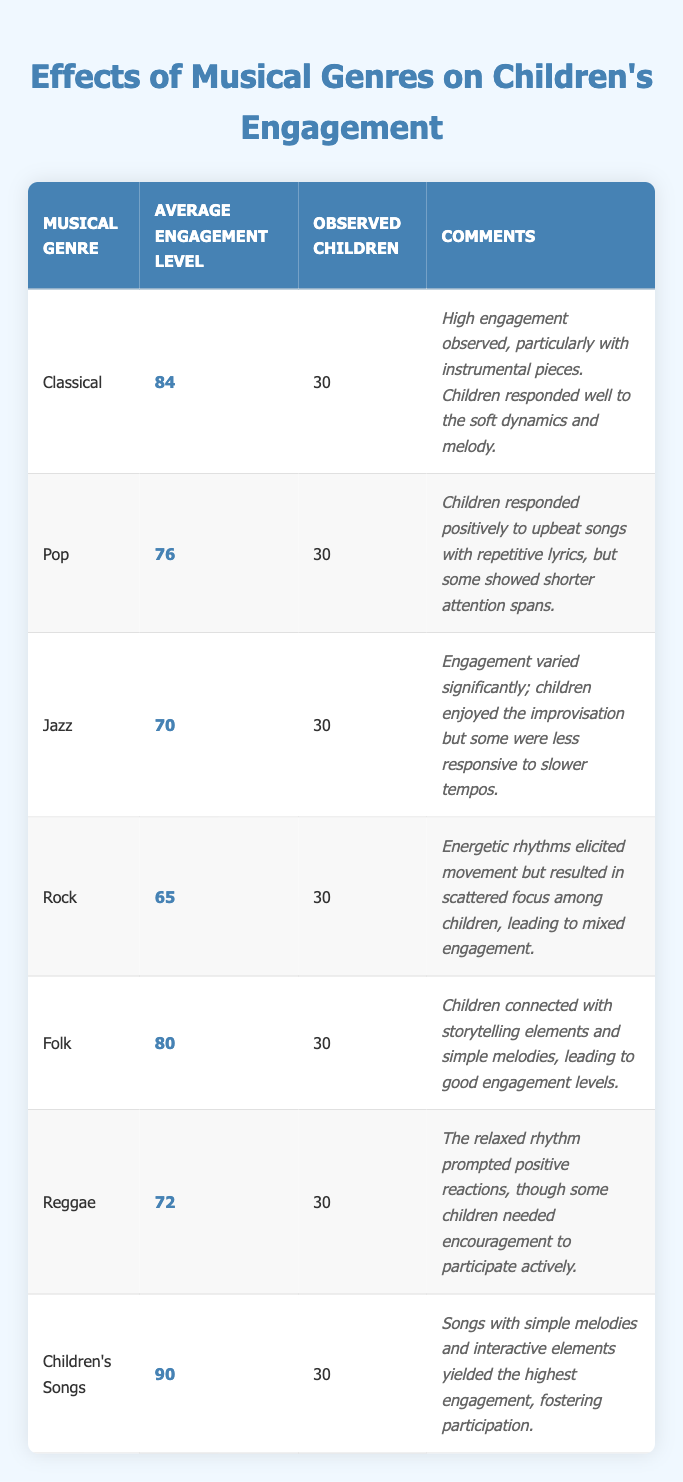What is the average engagement level for Classical music? The table shows that the average engagement level for Classical music is listed directly in the corresponding row. It is 84.
Answer: 84 Which musical genre had the highest average engagement level? By comparing the average engagement levels in the table, Children's Songs have the highest average engagement level at 90.
Answer: Children's Songs How many children were observed for each musical genre? The table indicates that the number of observed children for each genre is consistently 30 across all entries.
Answer: 30 What is the average engagement level of all the musical genres combined? To find the average engagement level, sum all the average engagement levels (84 + 76 + 70 + 65 + 80 + 72 + 90 = 537) and divide by the number of genres (7). The average is 537 / 7 = 76.71.
Answer: 76.71 Does Pop music show a higher engagement level than Jazz? The table shows that Pop music has an average engagement level of 76, while Jazz has 70. Since 76 is greater than 70, Pop does have a higher engagement level than Jazz.
Answer: Yes What is the difference in engagement level between Children's Songs and Rock? The average engagement level for Children's Songs is 90, while Rock is 65. The difference is calculated by subtracting Rock's level from Children's Songs' level (90 - 65 = 25).
Answer: 25 Which musical genres elicited movement among children? The comments for Rock indicate energetic rhythms elicited movement. Additionally, Jazz mentioned children enjoyed improvisation, which can also suggest movement. Although Rock is more focused on movement, Jazz's level of engagement varied.
Answer: Rock and Jazz What can be inferred about the engagement of children with Folk music? The table indicates that Folk music had an average engagement level of 80 and children connected with its storytelling elements and simple melodies. This suggests that Folk music is quite engaging for children.
Answer: Folk music is engaging Do children show better engagement levels with slower or faster music genres according to the table? The data shows that genres with slower music (like Jazz and Rock) had lower engagement levels compared to Children's Songs and Folk, which are more interactive or melodic. This suggests children may prefer faster, more interactive music for higher engagement.
Answer: Faster music genres Which genre shows a positive aspect but also indicates the need for encouragement? The Reggae genre mentions that while the relaxed rhythm prompted positive reactions, some children needed encouragement to participate actively. This indicates a positive aspect but also a limitation in engagement.
Answer: Reggae 